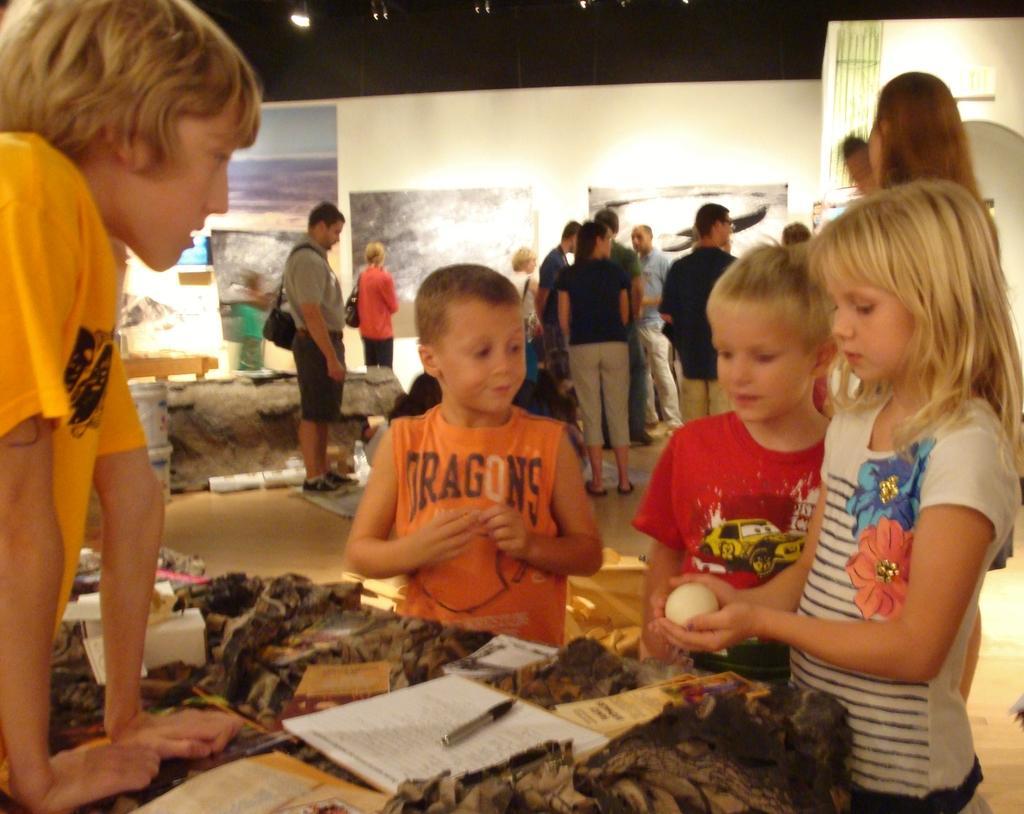Please provide a concise description of this image. Here we can see group of people. There is a cloth, books, and a marker. In the background we can see a wall with posters and a light. 